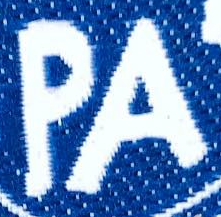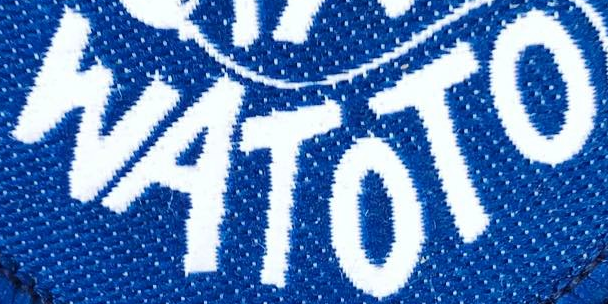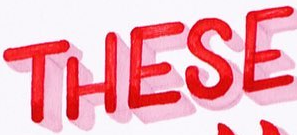What text is displayed in these images sequentially, separated by a semicolon? PA; WATOTO; THESE 